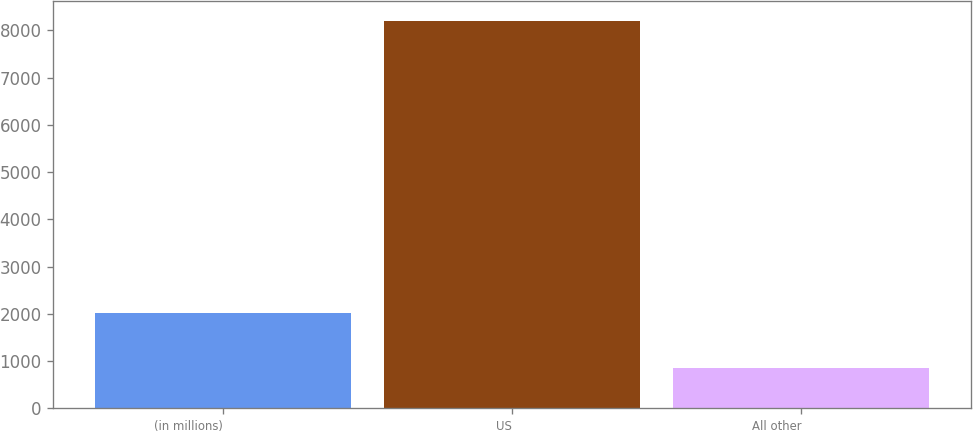<chart> <loc_0><loc_0><loc_500><loc_500><bar_chart><fcel>(in millions)<fcel>US<fcel>All other<nl><fcel>2013<fcel>8204<fcel>854<nl></chart> 